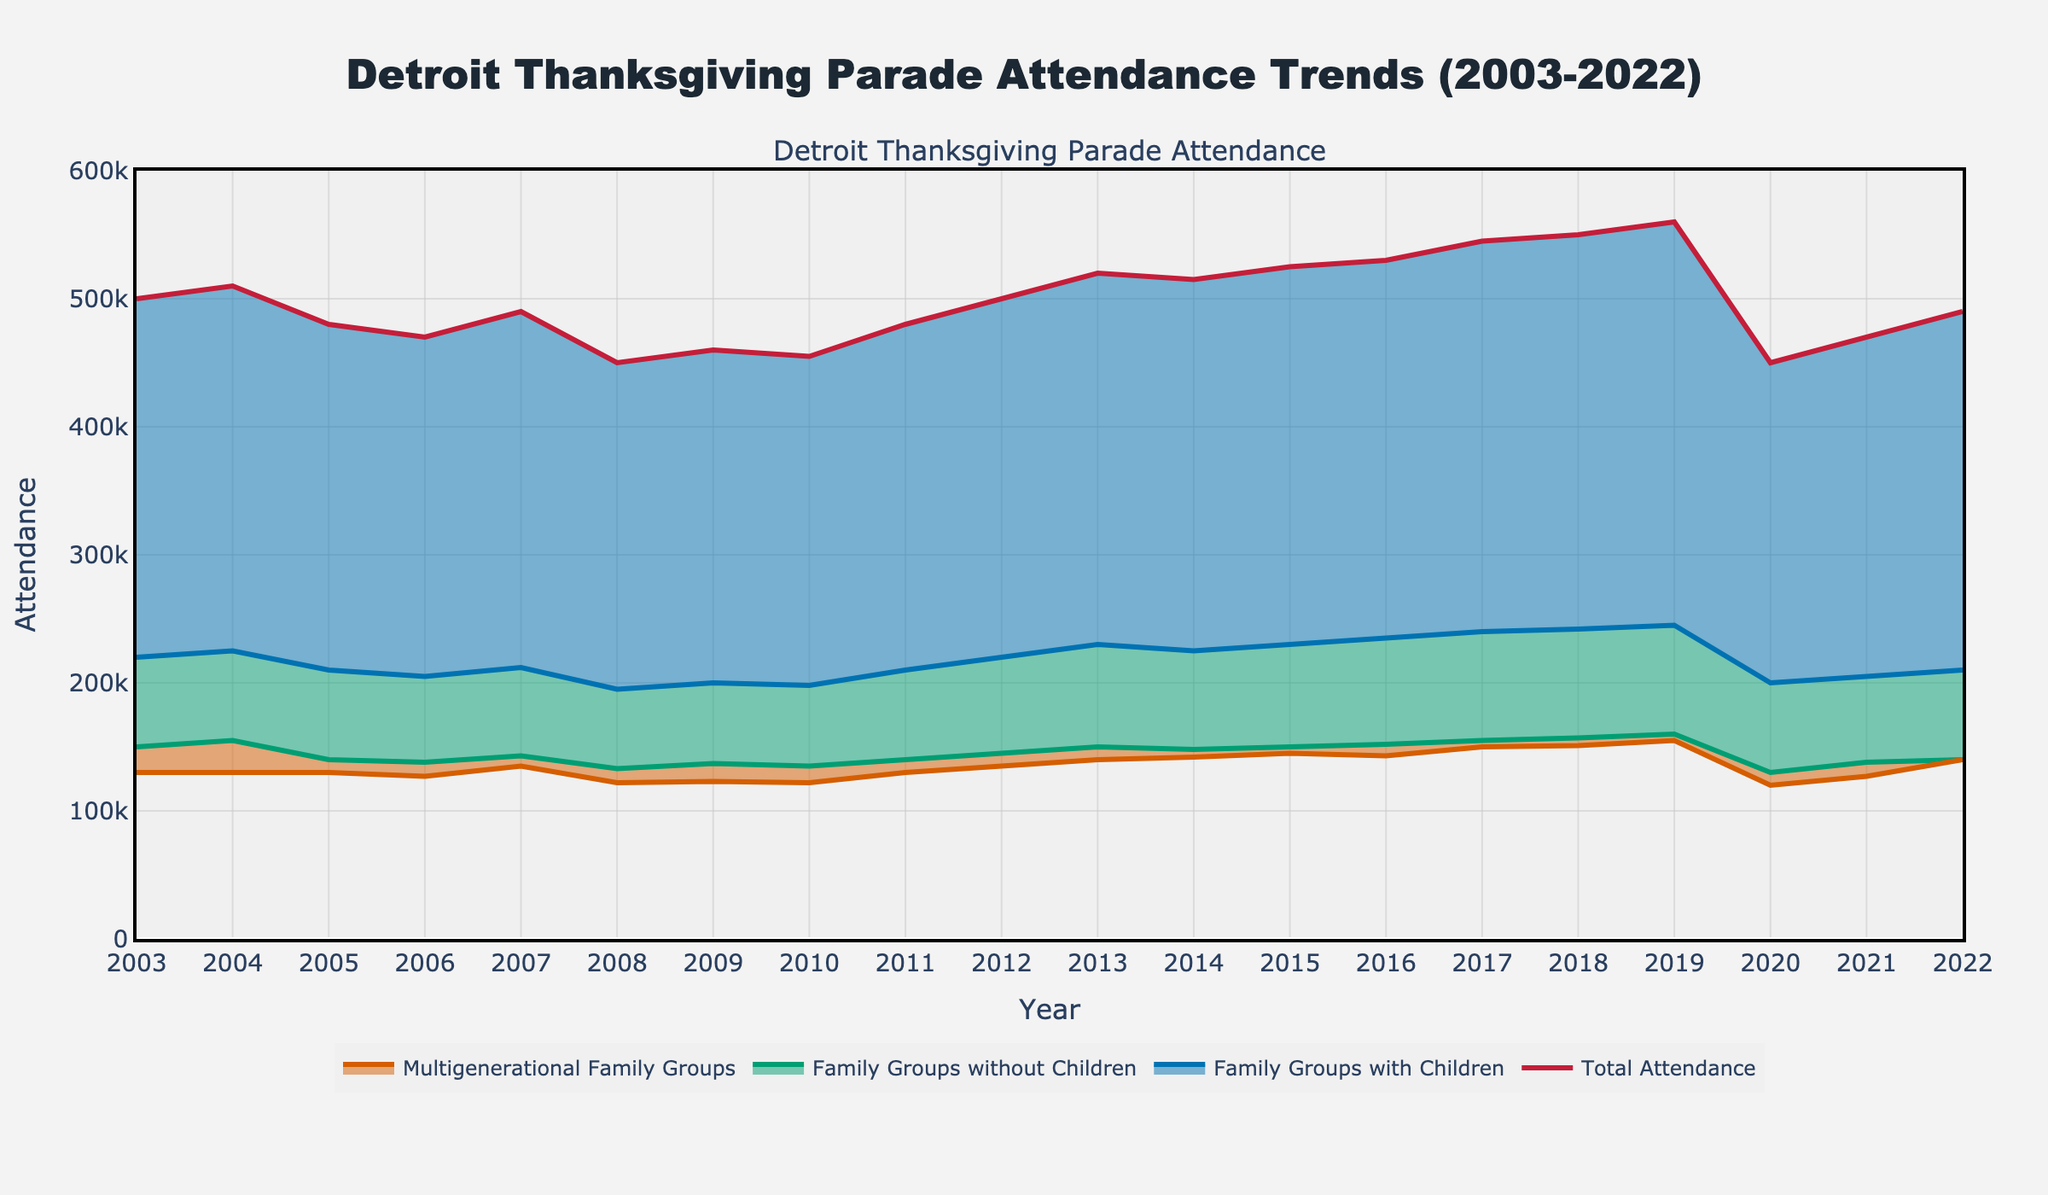What's the total attendance in 2015? Look at the data point for 2015 on the "Total Attendance" line in the plot, which shows the number for that year.
Answer: 525,000 Which year had the lowest attendance, and what was that number? Examine the "Total Attendance" line for the lowest data point across all years.
Answer: 2020, 450,000 How did attendance trends change between 2008 and 2012? Observe the "Total Attendance" line from 2008 to 2012: it starts at 450,000 in 2008, goes up and down slightly, and reaches 500,000 by 2012.
Answer: Increased, net gain of 50,000 In which year did 'Family Groups with Children' see their highest attendance? Look along the "Family Groups with Children" line for the peak value among all years.
Answer: 2019 Compare the number of 'Multigenerational Family Groups' in 2003 and 2022. What is the percentage change? Find the 'Multigenerational Family Groups' values for 2003 and 2022. The 2003 value is 130,000 and the 2022 value is 140,000. Calculate the percentage change: (140,000 - 130,000) / 130,000 * 100.
Answer: 7.69% Which year saw a greater number of 'Family Groups without Children', 2007 or 2014? By how much? Compare the 'Family Groups without Children' values for 2007 (143,000) and 2014 (148,000). Subtract the smaller number from the larger one.
Answer: 2014 by 5,000 What is the average attendance from 2010 to 2019? Sum the 'Total Attendance' values from 2010 to 2019 and divide by the number of years (10): (455,000 + 480,000 + 500,000 + 520,000 + 515,000 + 525,000 + 530,000 + 545,000 + 550,000 + 560,000) / 10.
Answer: 518,000 How did 'Multigenerational Family Groups' change after 2020? Look at the 'Multigenerational Family Groups' line around the year 2020, then check the years following it (2021, 2022). In 2020, the number is 120,000, rising to 140,000 by 2022.
Answer: Increased by 20,000 Did any family composition group have steady attendance from 2003 to 2022? Compare all family composition trends in the plot for a consistent (steady) pattern from 2003 to 2022. No group maintains an exact steady value, but some display smoother trends with less drastic changes.
Answer: No fully steady group, but 'Family Groups without Children' show smoother trends 